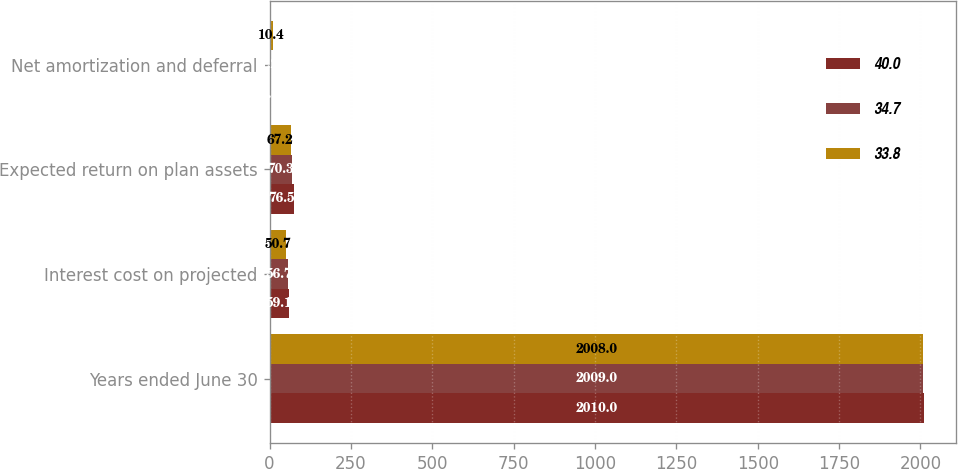<chart> <loc_0><loc_0><loc_500><loc_500><stacked_bar_chart><ecel><fcel>Years ended June 30<fcel>Interest cost on projected<fcel>Expected return on plan assets<fcel>Net amortization and deferral<nl><fcel>40<fcel>2010<fcel>59.1<fcel>76.5<fcel>4.5<nl><fcel>34.7<fcel>2009<fcel>56.7<fcel>70.3<fcel>1.2<nl><fcel>33.8<fcel>2008<fcel>50.7<fcel>67.2<fcel>10.4<nl></chart> 